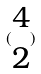<formula> <loc_0><loc_0><loc_500><loc_500>( \begin{matrix} 4 \\ 2 \end{matrix} )</formula> 